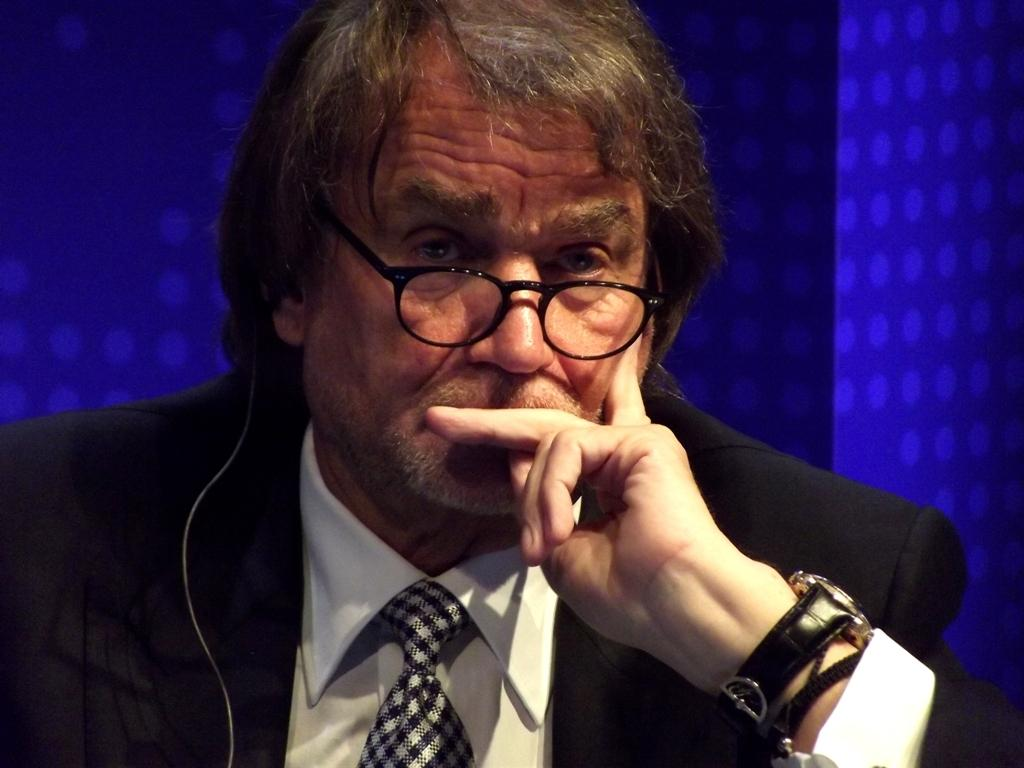Who is the main subject in the picture? There is an old man in the picture. What is the old man wearing? The old man is wearing a black suit. Where is the old man sitting in the image? The old man is sitting in the front. What is the old man doing with his hand? The old man has his hand on his chin. What might the old man be doing or thinking? The old man appears to be thinking. What color is the background in the image? The background in the image is blue. What type of cloth is being used to hold the screw in the image? There is no cloth or screw present in the image; it features an old man sitting and thinking. 